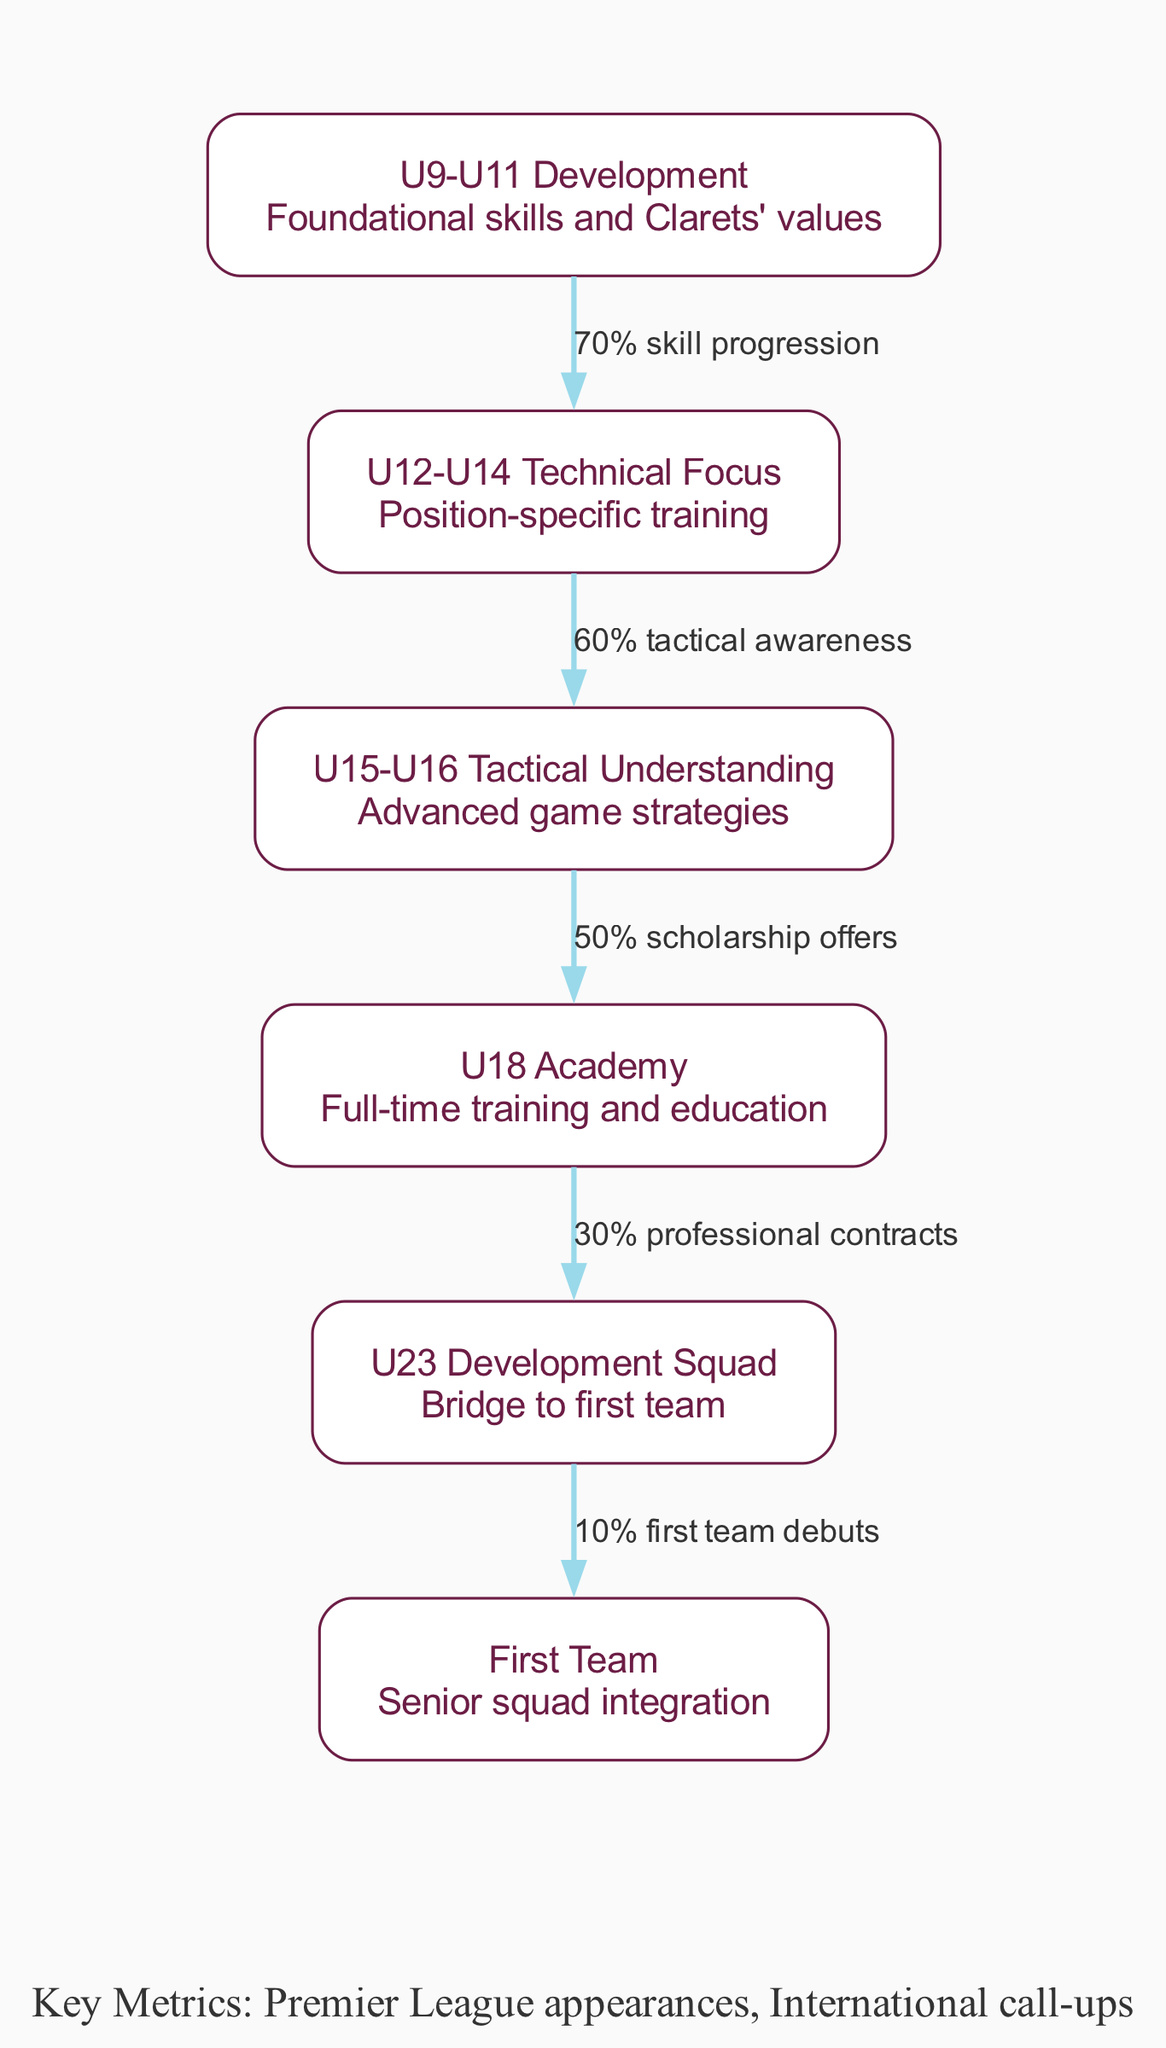What's the first stage of player development in Burnley's youth academy? The diagram lists "U9-U11 Development" as the first stage, which focuses on foundational skills and the values of Burnley Football Club.
Answer: U9-U11 Development What percentage of players progress from U12-U14 Technical Focus to U15-U16 Tactical Understanding? In the diagram, it shows a connection from U12-U14 Technical Focus to U15-U16 Tactical Understanding with a label stating "60% tactical awareness," indicating the percentage of players who improve their tactical understanding at this stage.
Answer: 60% How many key stages are there in Burnley's player development pathway? By counting the nodes listed in the diagram, we see there are six distinct stages within Burnley's youth academy pathway.
Answer: 6 What is the final stage before players can potentially debut for the first team? The diagram indicates that the final stage before attempting to join the first team is the "U23 Development Squad," which serves as a bridge to the senior squad.
Answer: U23 Development Squad What is the success metric for transitioning from the U18 Academy to the U23 Development Squad? The relationship from the U18 Academy to the U23 Development Squad in the diagram is labeled "30% professional contracts," which details the success metric for this transition.
Answer: 30% professional contracts Which stage has the highest skill progression percentage? Analyzing the connections in the diagram, "U9-U11 Development" has a "70% skill progression" label connecting it to the next stage, indicating it has the highest percentage of skill progression.
Answer: 70% What annotation at the bottom of the diagram refers to additional success metrics observed in the youth academy? The annotation at the bottom of the diagram mentions "Key Metrics: Premier League appearances, International call-ups," indicating the types of achievements expected from players following the development pathway.
Answer: Key Metrics: Premier League appearances, International call-ups What is the transition percentage from U23 Development Squad to the First Team? The edge from U23 Development Squad to the First Team is labeled "10% first team debuts," representing the transition percentage indicating how many players make it to the first team from that stage.
Answer: 10% first team debuts 